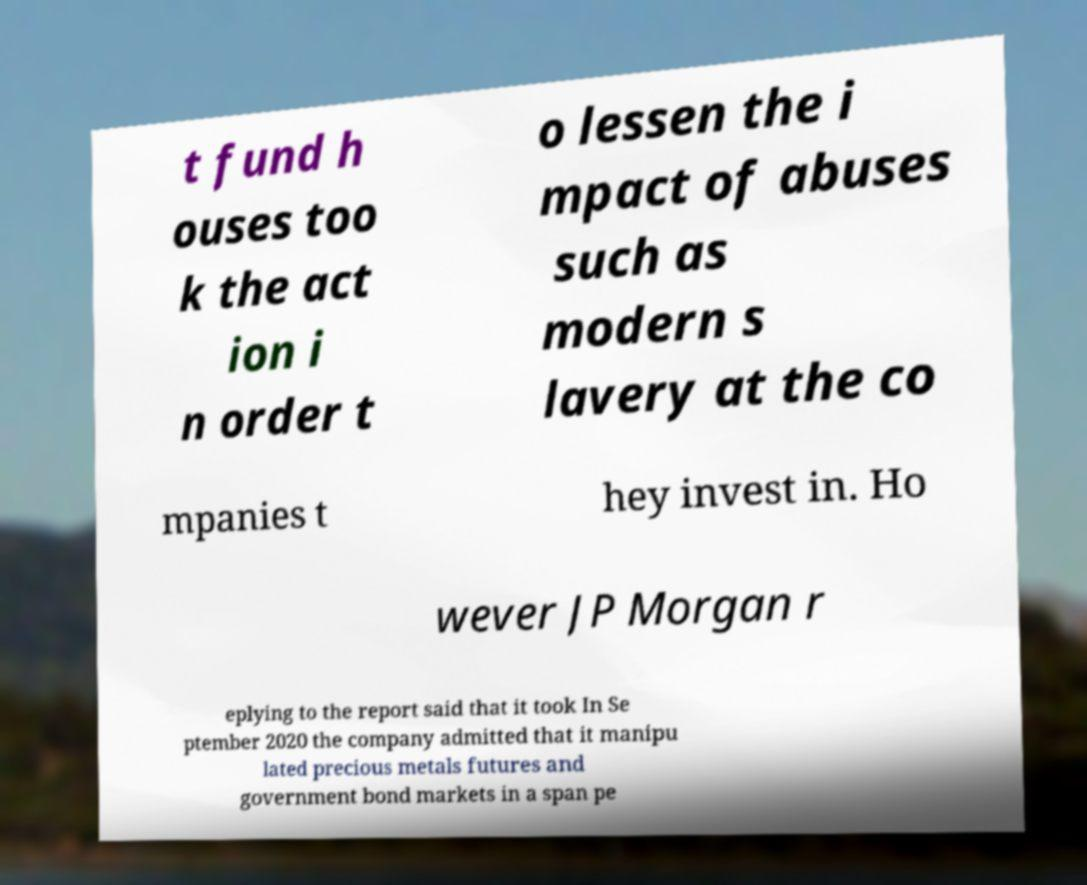I need the written content from this picture converted into text. Can you do that? t fund h ouses too k the act ion i n order t o lessen the i mpact of abuses such as modern s lavery at the co mpanies t hey invest in. Ho wever JP Morgan r eplying to the report said that it took In Se ptember 2020 the company admitted that it manipu lated precious metals futures and government bond markets in a span pe 